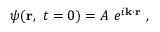<formula> <loc_0><loc_0><loc_500><loc_500>\psi ( r , \ t = 0 ) = A \ e ^ { i k \cdot r } \ ,</formula> 